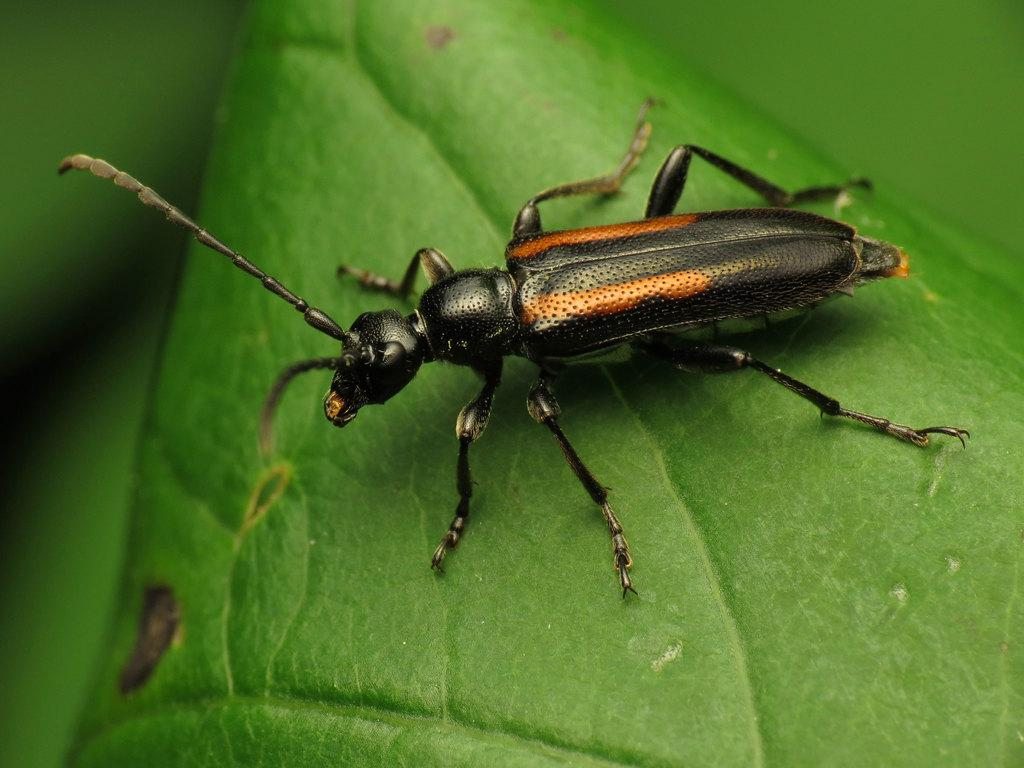What is the main subject of the picture? The main subject of the picture is an insect. Where is the insect located in the image? The insect is on a leaf. Can you describe the insect's body structure? The insect has a body, head, and legs. What can be observed about the background of the image? The backdrop of the image is blurred. What type of vase can be seen in the image? There is no vase present in the image; it features an insect on a leaf. What color is the yarn used to create the insect's legs? The insect is a real, living creature and does not have yarn legs. 